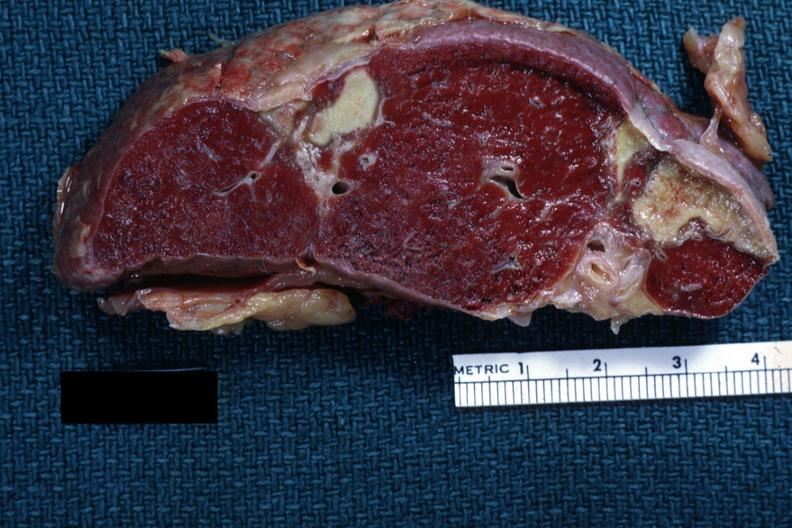what is present?
Answer the question using a single word or phrase. Spleen 